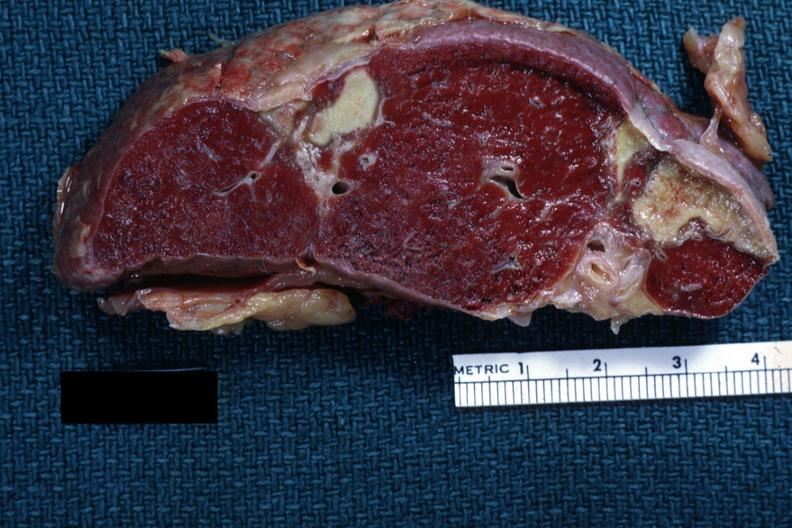what is present?
Answer the question using a single word or phrase. Spleen 